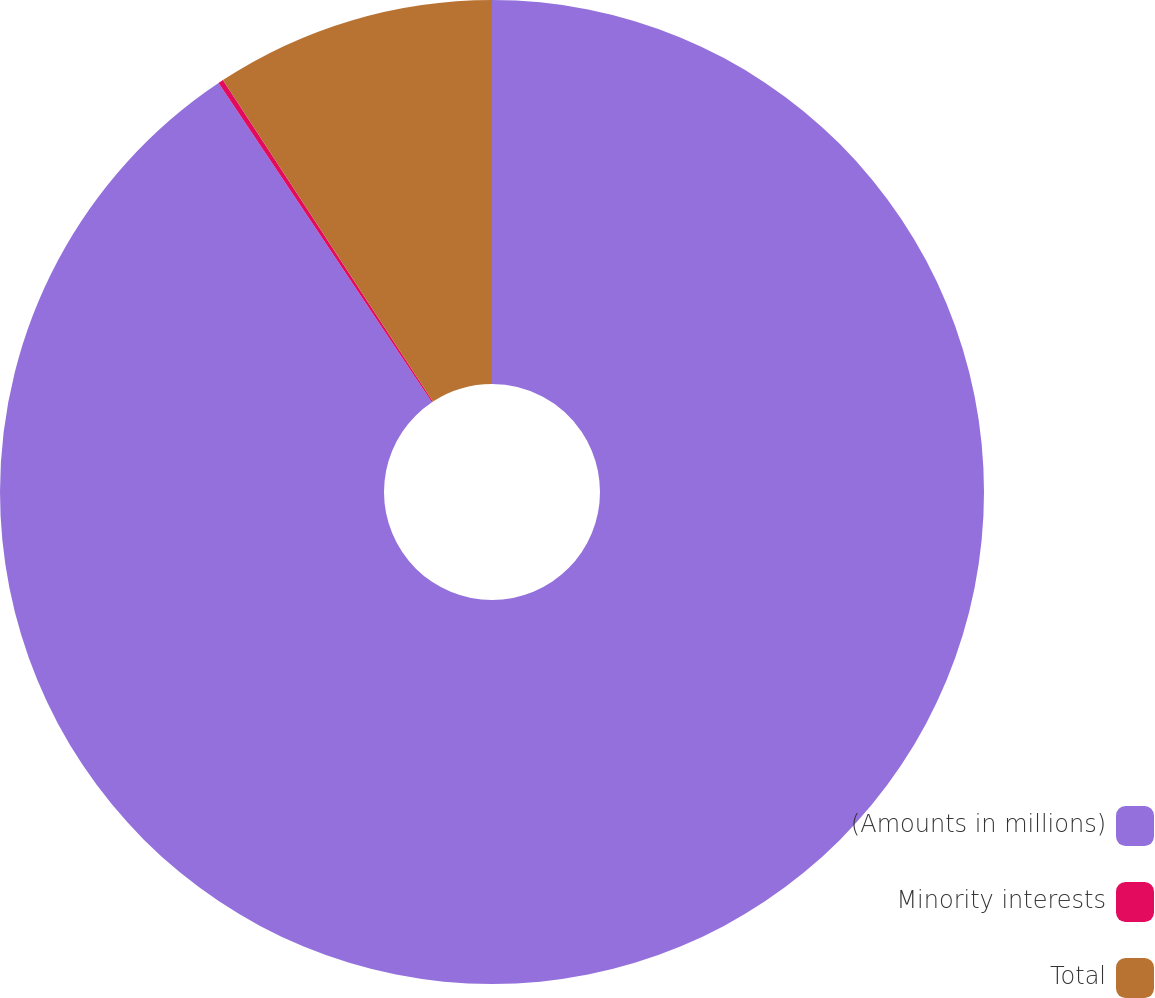Convert chart to OTSL. <chart><loc_0><loc_0><loc_500><loc_500><pie_chart><fcel>(Amounts in millions)<fcel>Minority interests<fcel>Total<nl><fcel>90.62%<fcel>0.17%<fcel>9.21%<nl></chart> 